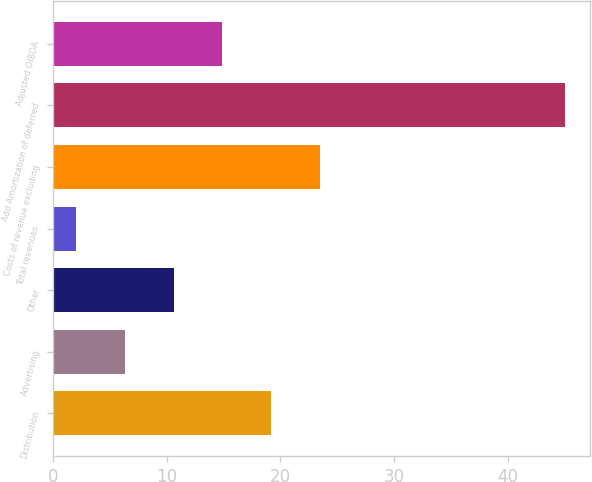<chart> <loc_0><loc_0><loc_500><loc_500><bar_chart><fcel>Distribution<fcel>Advertising<fcel>Other<fcel>Total revenues<fcel>Costs of revenue excluding<fcel>Add Amortization of deferred<fcel>Adjusted OIBDA<nl><fcel>19.2<fcel>6.3<fcel>10.6<fcel>2<fcel>23.5<fcel>45<fcel>14.9<nl></chart> 